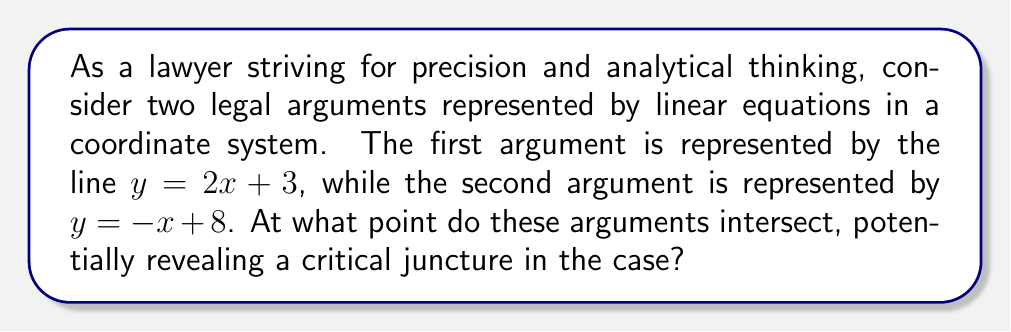Teach me how to tackle this problem. To find the intersection point of these two lines, we need to solve the system of equations:

1) $y = 2x + 3$
2) $y = -x + 8$

Step 1: Since both equations are equal to y, we can set them equal to each other:
$2x + 3 = -x + 8$

Step 2: Add x to both sides:
$3x + 3 = 8$

Step 3: Subtract 3 from both sides:
$3x = 5$

Step 4: Divide both sides by 3:
$x = \frac{5}{3}$

Step 5: Now that we know x, we can substitute this value into either of the original equations. Let's use the first one:

$y = 2(\frac{5}{3}) + 3$

Step 6: Simplify:
$y = \frac{10}{3} + 3 = \frac{10}{3} + \frac{9}{3} = \frac{19}{3}$

Therefore, the intersection point is $(\frac{5}{3}, \frac{19}{3})$.
Answer: $(\frac{5}{3}, \frac{19}{3})$ 